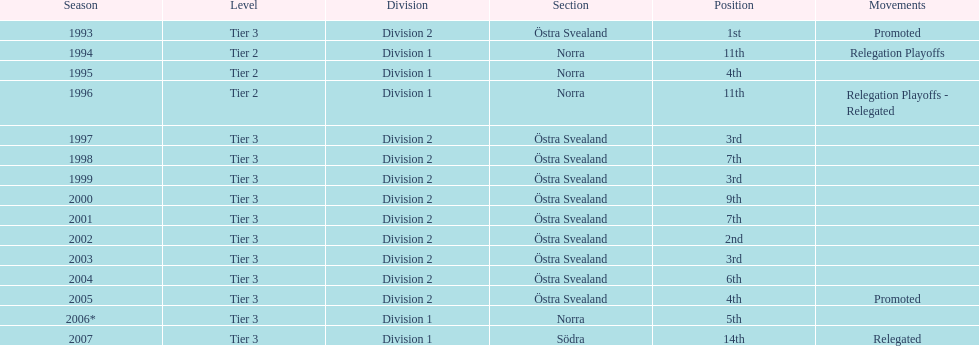What is the sole year with the 1st rank? 1993. 